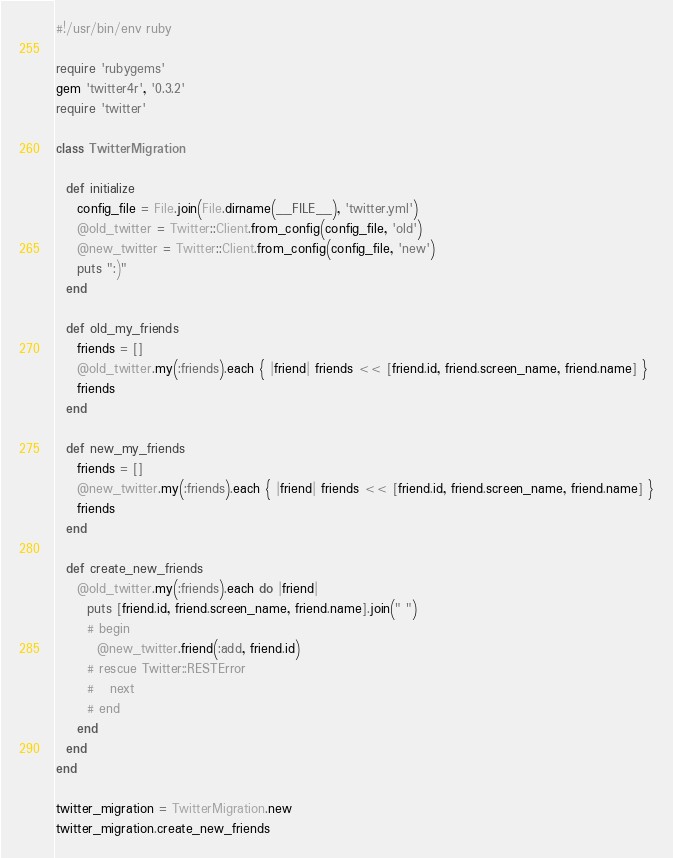Convert code to text. <code><loc_0><loc_0><loc_500><loc_500><_Ruby_>#!/usr/bin/env ruby

require 'rubygems'
gem 'twitter4r', '0.3.2'
require 'twitter'

class TwitterMigration

  def initialize
    config_file = File.join(File.dirname(__FILE__), 'twitter.yml')
    @old_twitter = Twitter::Client.from_config(config_file, 'old')
    @new_twitter = Twitter::Client.from_config(config_file, 'new')
    puts ":)"
  end

  def old_my_friends
    friends = []
    @old_twitter.my(:friends).each { |friend| friends << [friend.id, friend.screen_name, friend.name] }
    friends
  end

  def new_my_friends
    friends = []
    @new_twitter.my(:friends).each { |friend| friends << [friend.id, friend.screen_name, friend.name] }
    friends
  end

  def create_new_friends
    @old_twitter.my(:friends).each do |friend|
      puts [friend.id, friend.screen_name, friend.name].join(" ")
      # begin
        @new_twitter.friend(:add, friend.id)
      # rescue Twitter::RESTError
      #   next
      # end
    end
  end
end

twitter_migration = TwitterMigration.new
twitter_migration.create_new_friends
</code> 